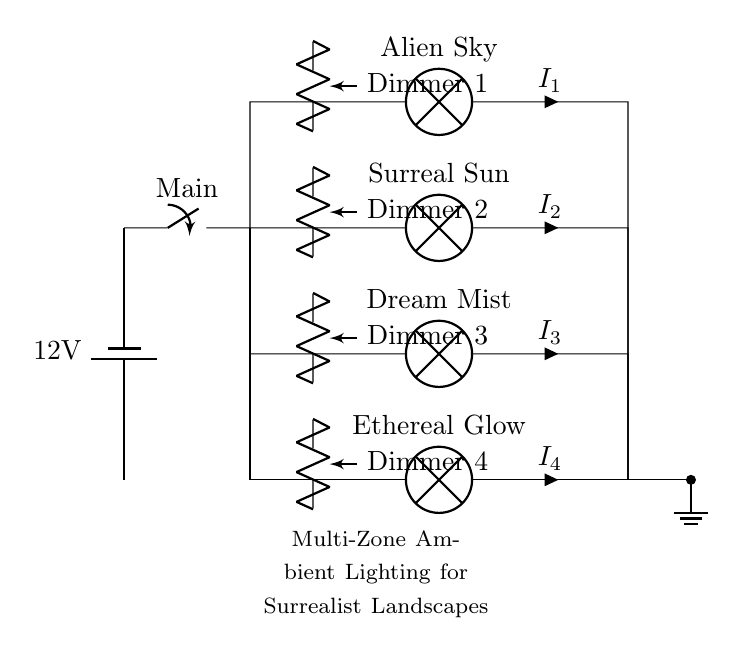What is the voltage of this circuit? The voltage is 12 volts, which is listed on the power supply component at the beginning of the circuit.
Answer: 12 volts How many lamps are in this circuit? There are four lamps, as indicated by the four lamp symbols in the parallel branches of the circuit diagram.
Answer: Four What is the current flowing through the lamp labeled "Surreal Sun"? The current flowing through "Surreal Sun" is denoted as I2; however, the circuit does not specify a numerical value for this current in the diagram.
Answer: I2 What role do the dimmers play in this circuit? The dimmers regulate the brightness of each individual lamp, allowing for control over the intensity of light emitted in each branch of the parallel circuit.
Answer: Brightness control How is the circuit grounded? The circuit is grounded via a short connection to a ground symbol at the bottom right of the diagram, indicating where the current returns to the earth.
Answer: Grounded What is the purpose of the main switch? The main switch controls the entire circuit, allowing the user to turn the whole lighting system on or off as needed.
Answer: On/Off control What type of circuit is shown in the diagram? The circuit shown is a parallel circuit, evident from the separate branches that allow each lamp to operate independently while being powered by the same voltage source.
Answer: Parallel 